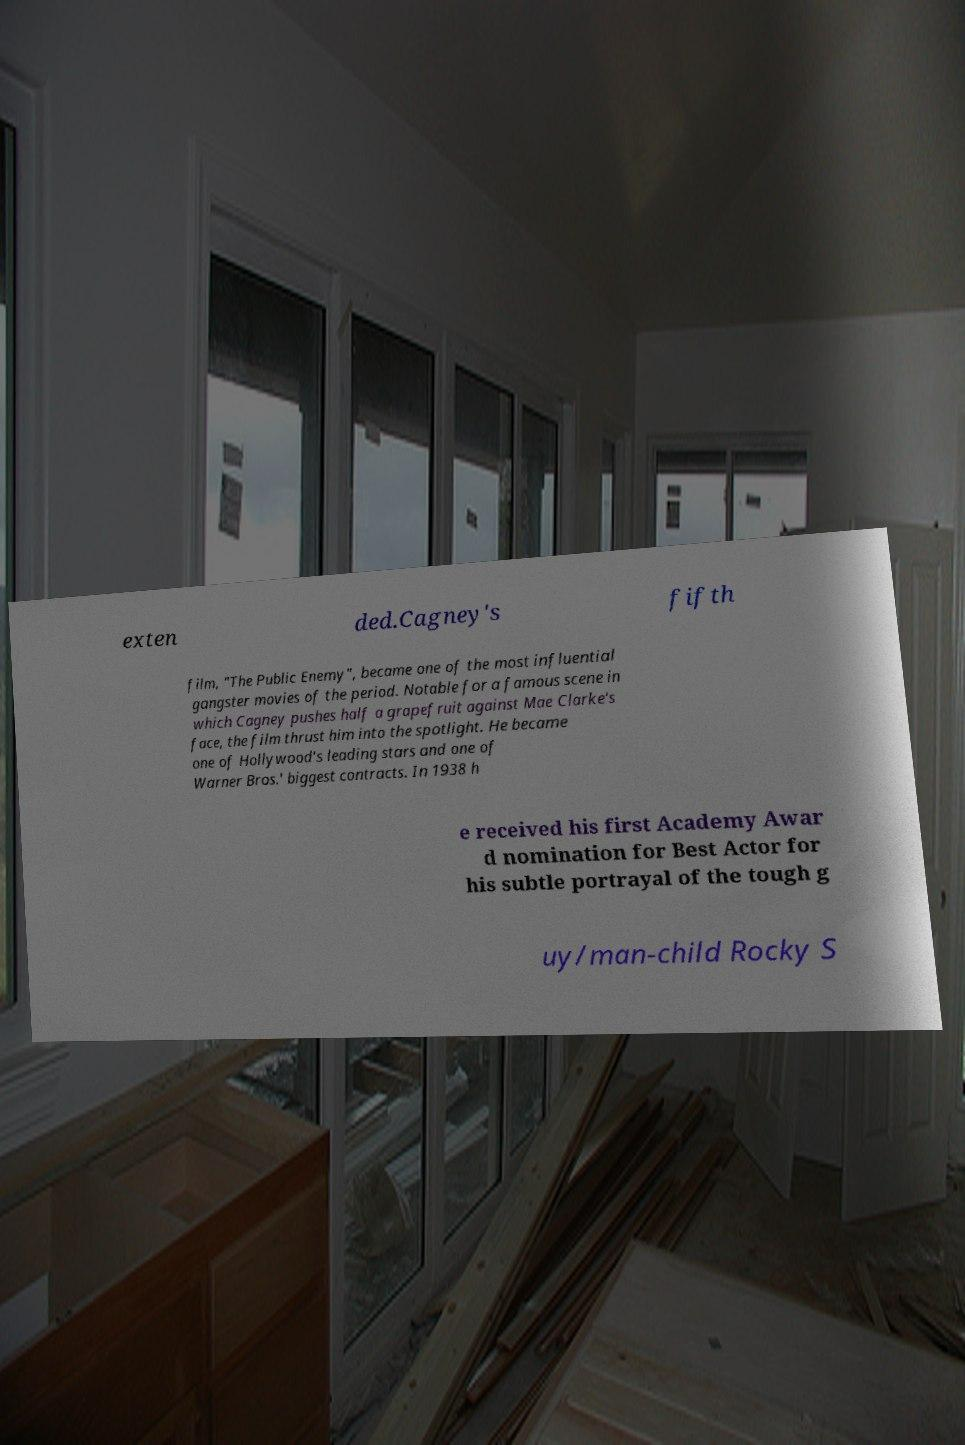Please identify and transcribe the text found in this image. exten ded.Cagney's fifth film, "The Public Enemy", became one of the most influential gangster movies of the period. Notable for a famous scene in which Cagney pushes half a grapefruit against Mae Clarke's face, the film thrust him into the spotlight. He became one of Hollywood's leading stars and one of Warner Bros.' biggest contracts. In 1938 h e received his first Academy Awar d nomination for Best Actor for his subtle portrayal of the tough g uy/man-child Rocky S 